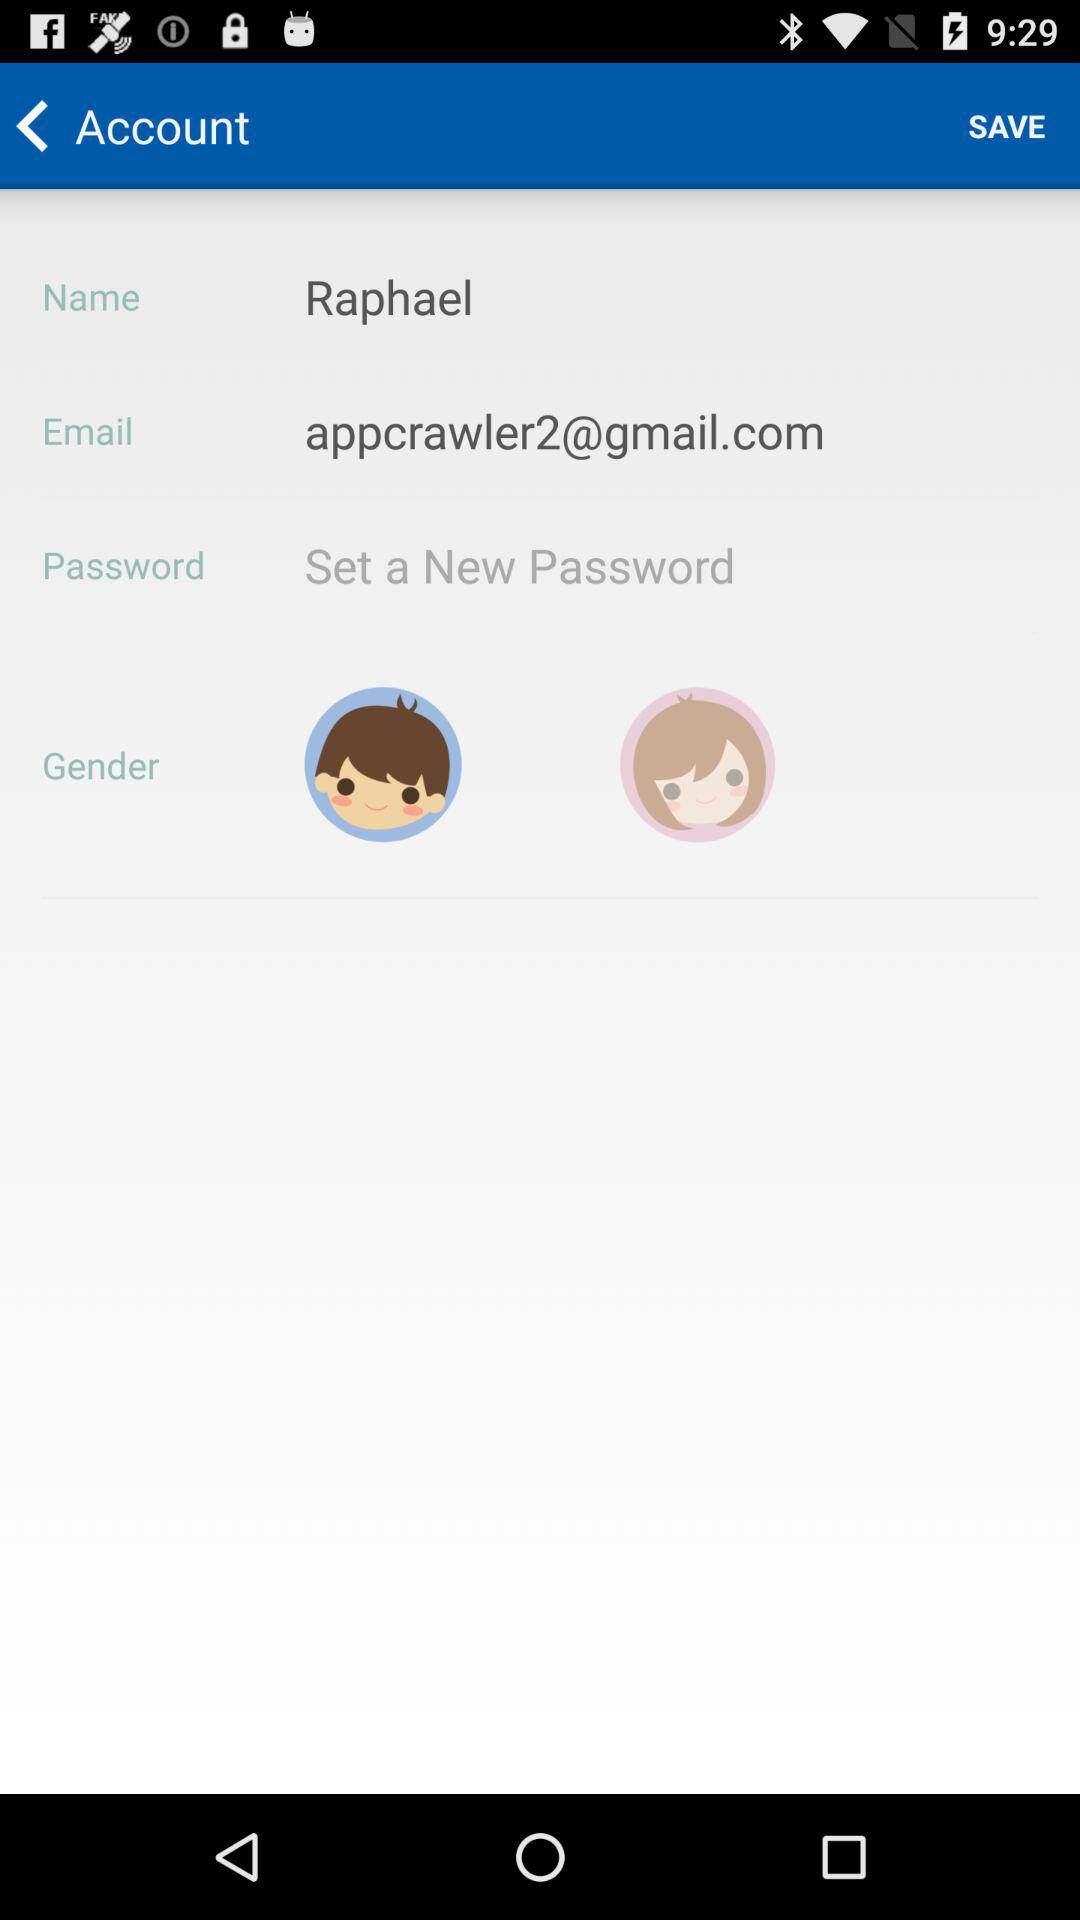What is the name? The name is Raphael. 